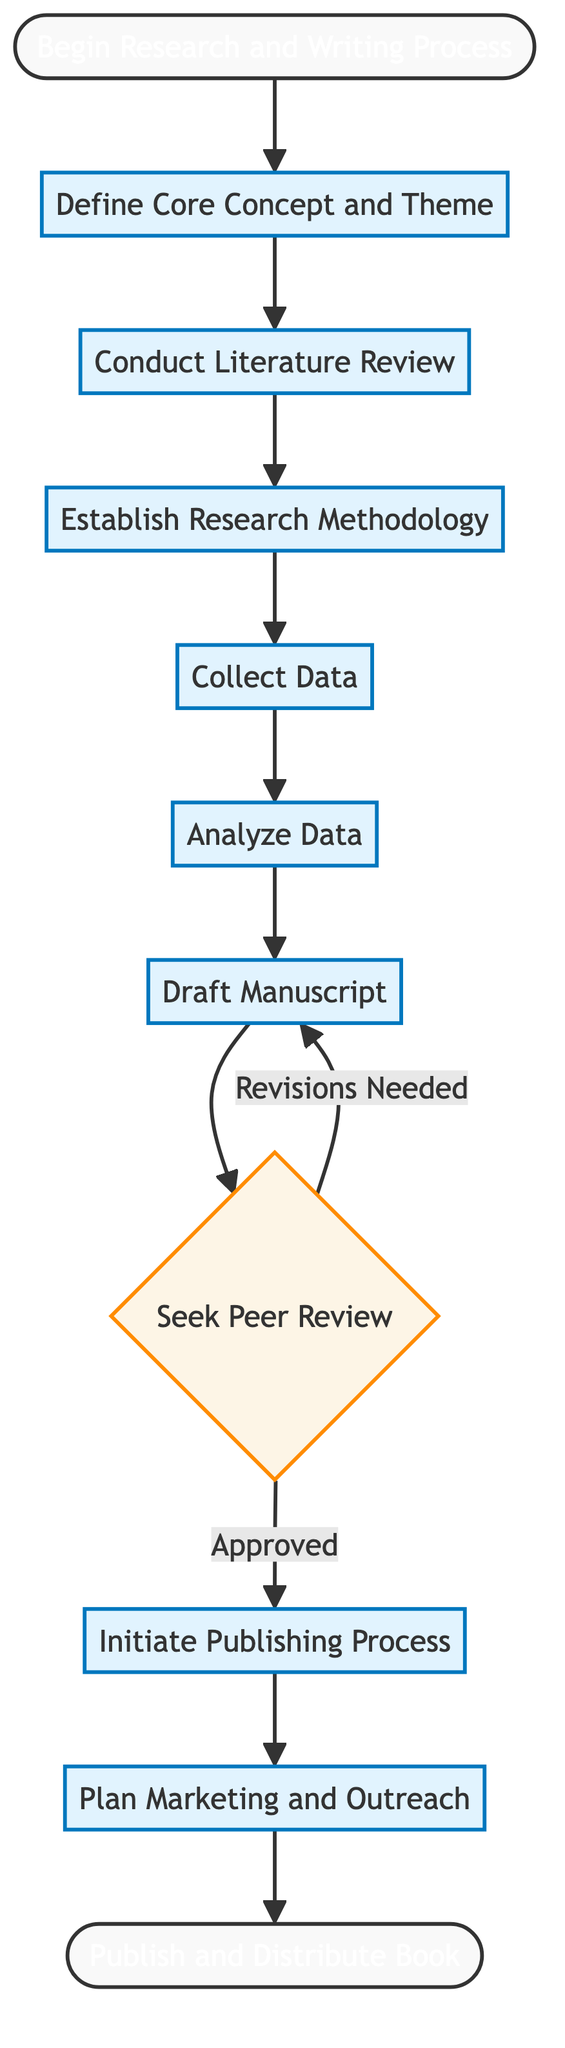What is the first step in the flowchart? The flowchart starts with the node labeled "Begin Research and Writing Process," indicating that this is the initial step in the process outlined.
Answer: Begin Research and Writing Process How many main steps are there in the process? By examining the flowchart, we can count the nodes representing distinct steps, which include "Define Core Concept and Theme," "Conduct Literature Review," "Establish Research Methodology," "Collect Data," "Analyze Data," "Draft Manuscript," "Seek Peer Review," "Initiate Publishing Process," and "Plan Marketing and Outreach." This totals to 9 main steps.
Answer: 9 What step follows after "Draft Manuscript"? The flowchart indicates that the step following "Draft Manuscript" is "Seek Peer Review," as there is a direct connection from one node to the other.
Answer: Seek Peer Review Which step has a decision point? The node "Seek Peer Review" includes a decision point identified by a diamond shape, indicating that this step can lead to two different paths: either "Revisions Needed" leading back to "Draft Manuscript," or "Approved" leading to the next step "Initiate Publishing Process."
Answer: Seek Peer Review What is the last step in the flowchart? The final step in the process as shown in the flowchart is "Publish and Distribute Book," which is the endpoint of the entire research and writing journey.
Answer: Publish and Distribute Book Which two steps are directly linked after "Analyze Data"? The flowchart shows a direct connection from "Analyze Data" to "Draft Manuscript," indicating that these two steps follow one another sequentially.
Answer: Draft Manuscript What is the main focus of the "Define Core Concept and Theme" step? The description of this step outlines that it is centered around identifying a central theme of religious diversity and formulating a unique perspective on interfaith tolerance. Thus, its main focus is on defining the core theme for the book.
Answer: Define the Core Concept and Theme How many iterations are possible after seeking peer review? The "Seek Peer Review" step can lead to two possible outcomes: if revisions are needed, it goes back to "Draft Manuscript," and if approved, it moves to "Initiate Publishing Process." Thus, there are two iterations possible.
Answer: 2 